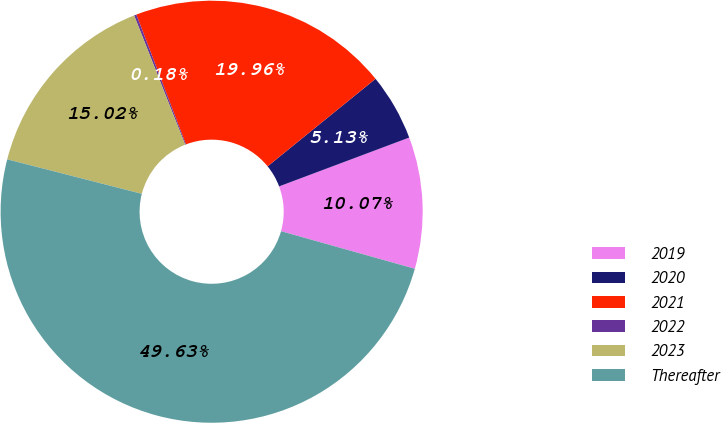Convert chart. <chart><loc_0><loc_0><loc_500><loc_500><pie_chart><fcel>2019<fcel>2020<fcel>2021<fcel>2022<fcel>2023<fcel>Thereafter<nl><fcel>10.07%<fcel>5.13%<fcel>19.96%<fcel>0.18%<fcel>15.02%<fcel>49.63%<nl></chart> 